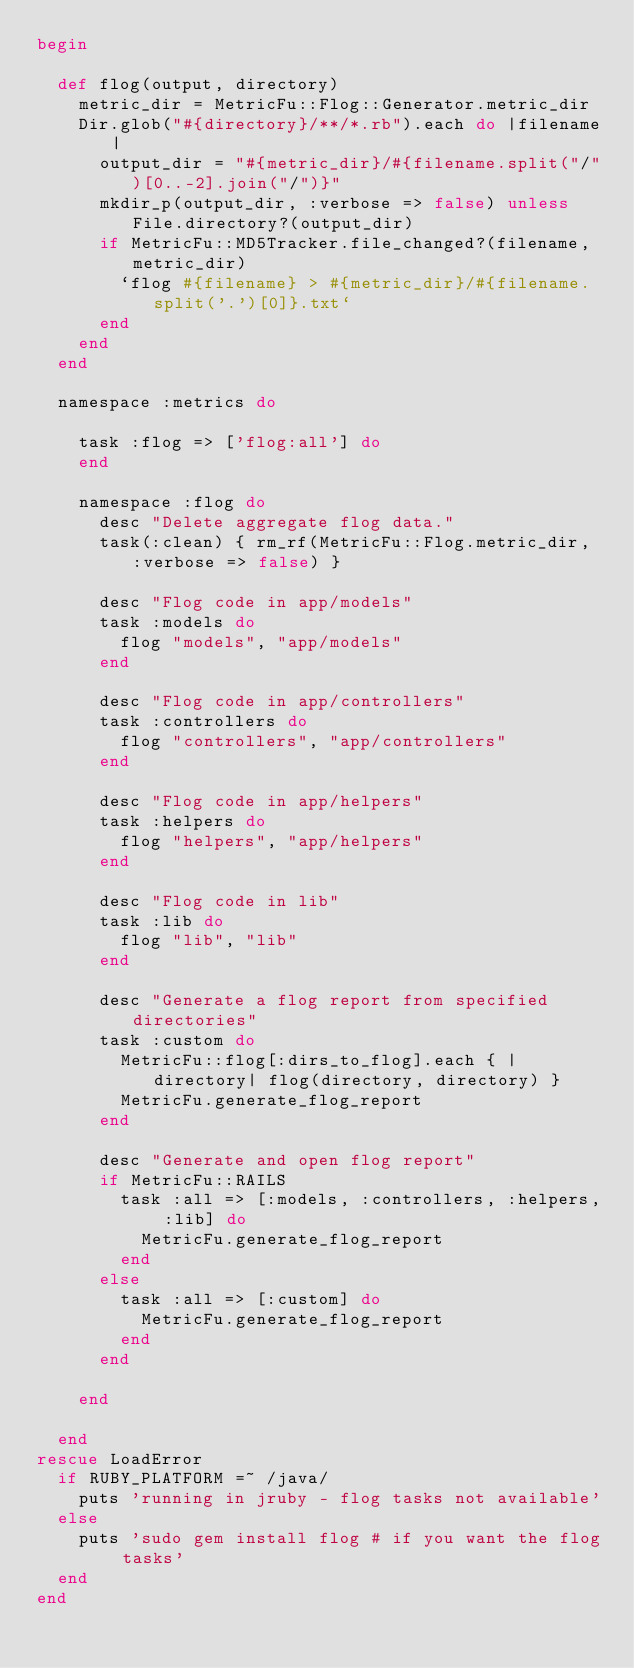Convert code to text. <code><loc_0><loc_0><loc_500><loc_500><_Ruby_>begin

  def flog(output, directory)
    metric_dir = MetricFu::Flog::Generator.metric_dir
    Dir.glob("#{directory}/**/*.rb").each do |filename|
      output_dir = "#{metric_dir}/#{filename.split("/")[0..-2].join("/")}"
      mkdir_p(output_dir, :verbose => false) unless File.directory?(output_dir)
      if MetricFu::MD5Tracker.file_changed?(filename, metric_dir)
        `flog #{filename} > #{metric_dir}/#{filename.split('.')[0]}.txt`
      end
    end
  end

  namespace :metrics do

    task :flog => ['flog:all'] do
    end

    namespace :flog do
      desc "Delete aggregate flog data."
      task(:clean) { rm_rf(MetricFu::Flog.metric_dir, :verbose => false) }

      desc "Flog code in app/models"
      task :models do
        flog "models", "app/models"
      end

      desc "Flog code in app/controllers"
      task :controllers do
        flog "controllers", "app/controllers"
      end

      desc "Flog code in app/helpers"
      task :helpers do
        flog "helpers", "app/helpers"
      end

      desc "Flog code in lib"
      task :lib do
        flog "lib", "lib"
      end

      desc "Generate a flog report from specified directories"
      task :custom do
        MetricFu::flog[:dirs_to_flog].each { |directory| flog(directory, directory) }
        MetricFu.generate_flog_report
      end

      desc "Generate and open flog report"
      if MetricFu::RAILS
        task :all => [:models, :controllers, :helpers, :lib] do
          MetricFu.generate_flog_report
        end
      else
        task :all => [:custom] do
          MetricFu.generate_flog_report
        end
      end

    end

  end
rescue LoadError
  if RUBY_PLATFORM =~ /java/
    puts 'running in jruby - flog tasks not available'
  else
    puts 'sudo gem install flog # if you want the flog tasks'
  end
end</code> 